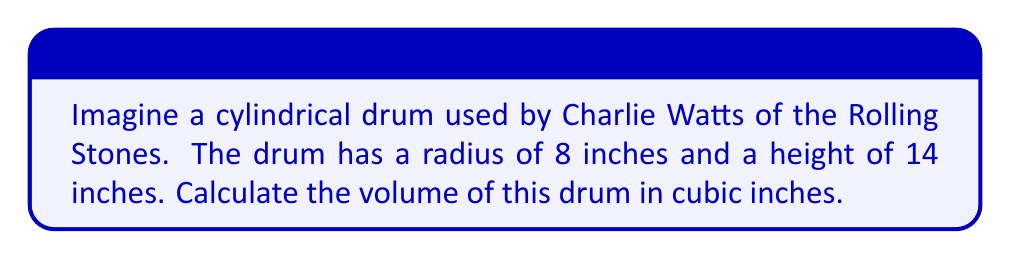Solve this math problem. To find the volume of a cylindrical drum, we use the formula:

$$V = \pi r^2 h$$

Where:
$V$ = volume
$r$ = radius of the base
$h$ = height of the cylinder

Given:
$r = 8$ inches
$h = 14$ inches

Let's substitute these values into the formula:

$$V = \pi (8 \text{ in})^2 (14 \text{ in})$$

Simplify:
$$V = \pi (64 \text{ in}^2) (14 \text{ in})$$
$$V = 896\pi \text{ in}^3$$

Calculate the final value (rounded to the nearest cubic inch):
$$V \approx 2,814 \text{ in}^3$$

[asy]
import geometry;

size(200);
real r = 4;
real h = 7;

path base = circle((0,0),r);
path top = circle((0,h),r);

draw(base);
draw(top);
draw((r,0)--(r,h));
draw((-r,0)--(-r,h));

label("r", (r/2,0), E);
label("h", (r,h/2), E);
[/asy]
Answer: $2,814 \text{ in}^3$ 